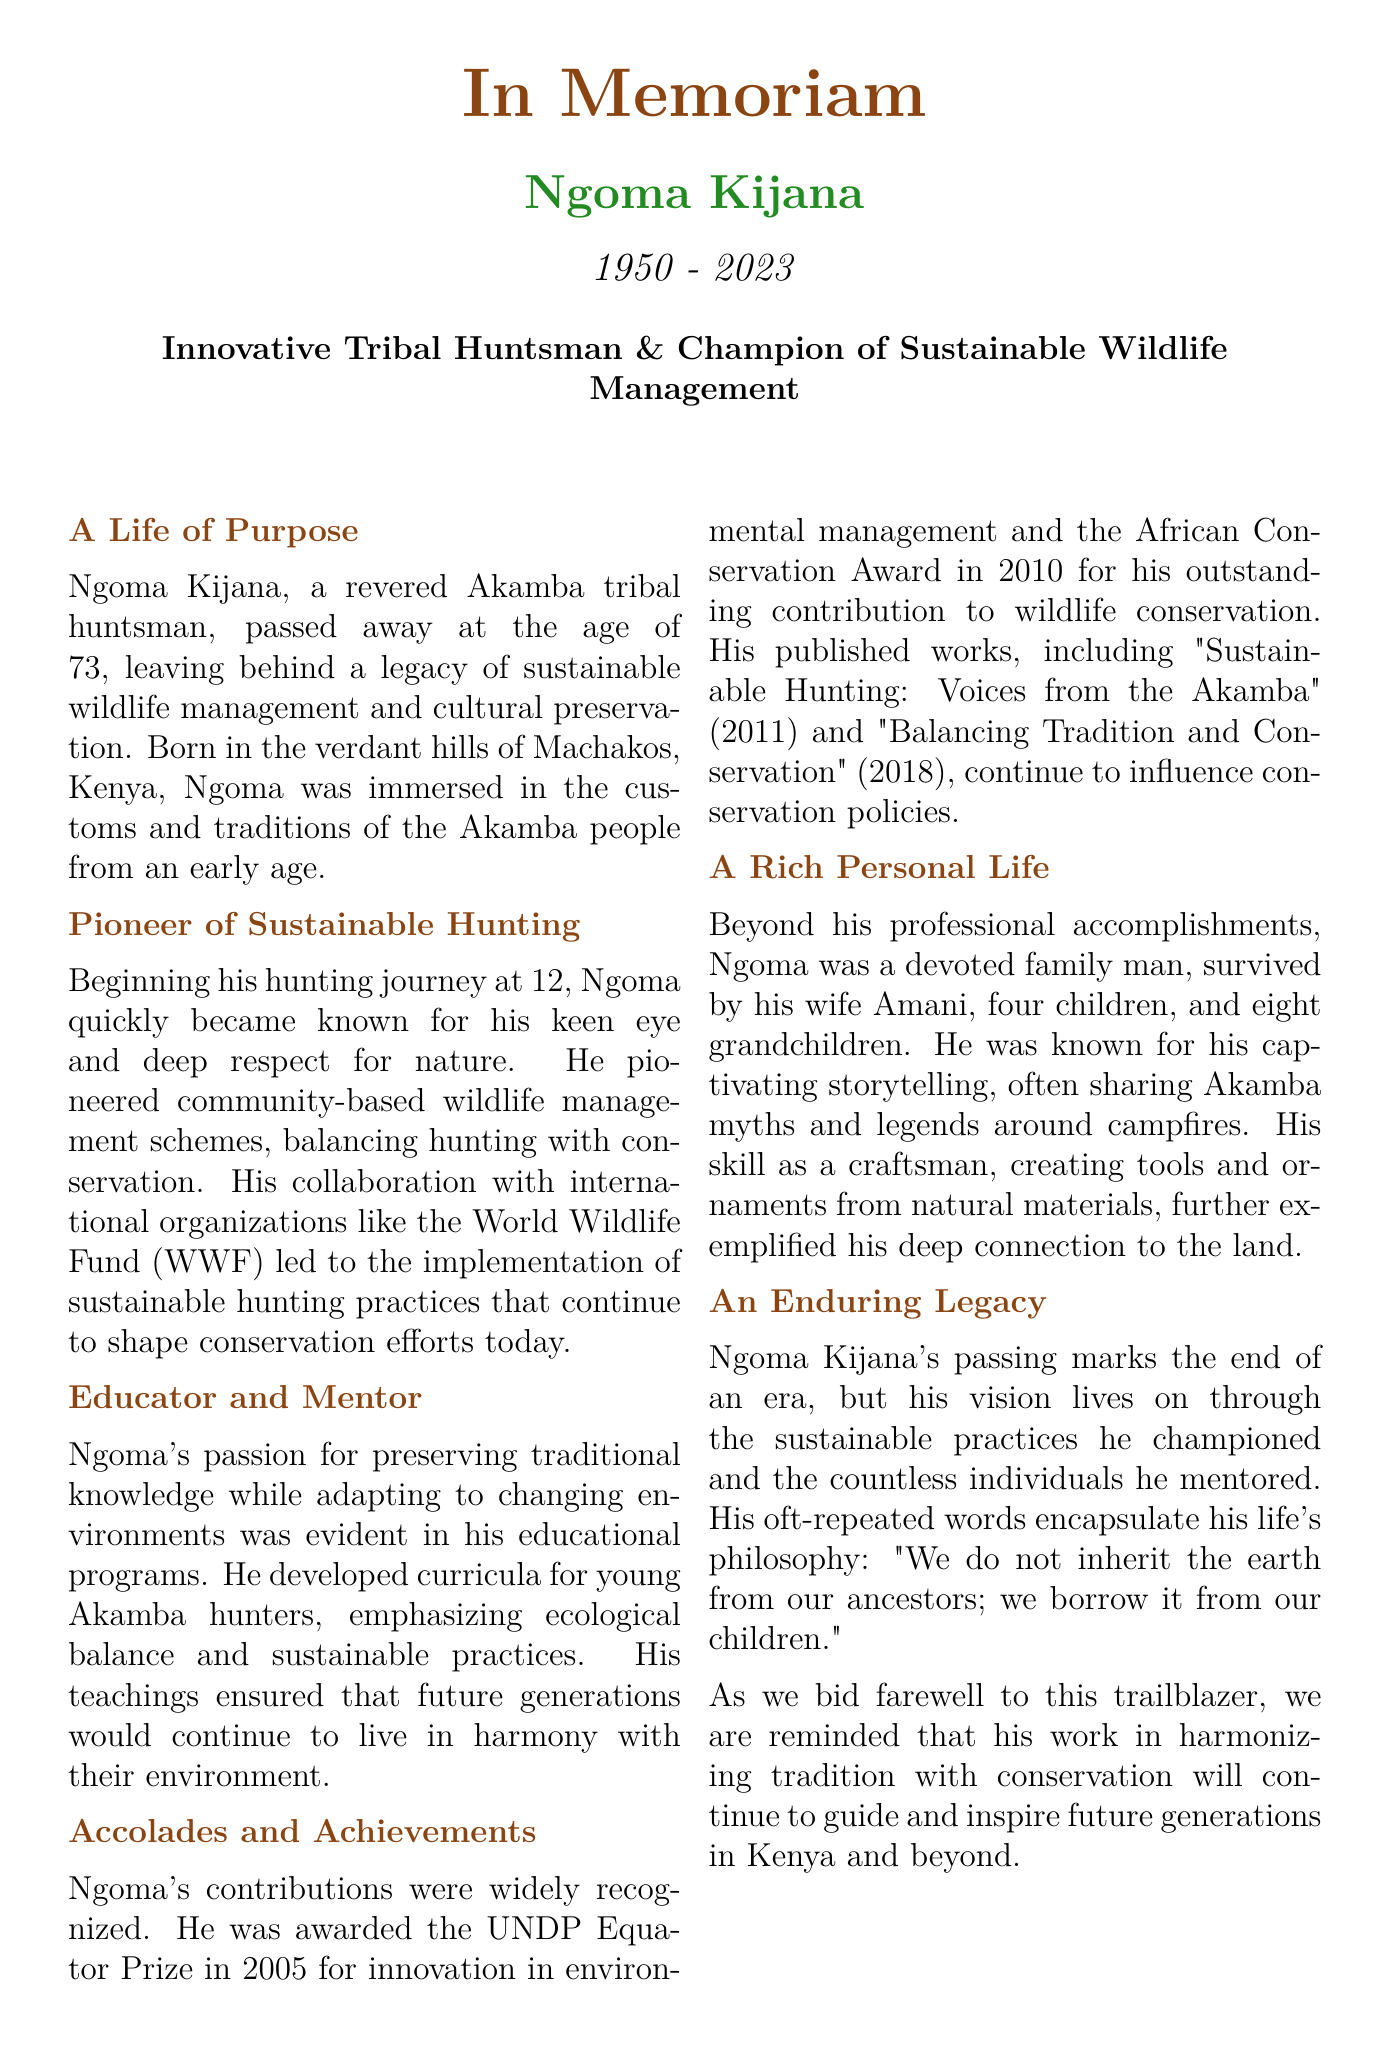what is the full name of the tribal huntsman? The document states the name of the tribal huntsman in the title.
Answer: Ngoma Kijana what year was Ngoma Kijana born? The document provides Ngoma's birth year in the initial details.
Answer: 1950 how old was Ngoma Kijana at the time of his passing? The document mentions his age at the time of death in the introduction.
Answer: 73 what prestigious award did Ngoma win in 2005? The document lists the award he received in 2005 under accolades and achievements.
Answer: UNDP Equator Prize what influential publication did Ngoma release in 2011? The document mentions one of his works published in 2011 under accolades and achievements.
Answer: Sustainable Hunting: Voices from the Akamba what was Ngoma Kijana's role in wildlife management? The document describes his contributions to wildlife management in the pioneer section.
Answer: Champion of Sustainable Wildlife Management how many grandchildren did Ngoma Kijana have? The document mentions the number of grandchildren he had in the personal life section.
Answer: Eight which two environmental values did Ngoma emphasize in his teachings? The document states key values he focused on in his educational programs.
Answer: Ecological balance and sustainable practices what year did Ngoma Kijana pass away? The document provides the year of his passing in the introductory section.
Answer: 2023 